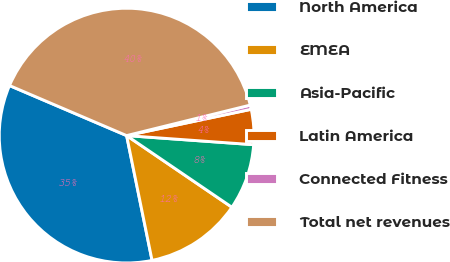Convert chart to OTSL. <chart><loc_0><loc_0><loc_500><loc_500><pie_chart><fcel>North America<fcel>EMEA<fcel>Asia-Pacific<fcel>Latin America<fcel>Connected Fitness<fcel>Total net revenues<nl><fcel>34.63%<fcel>12.29%<fcel>8.37%<fcel>4.45%<fcel>0.54%<fcel>39.72%<nl></chart> 